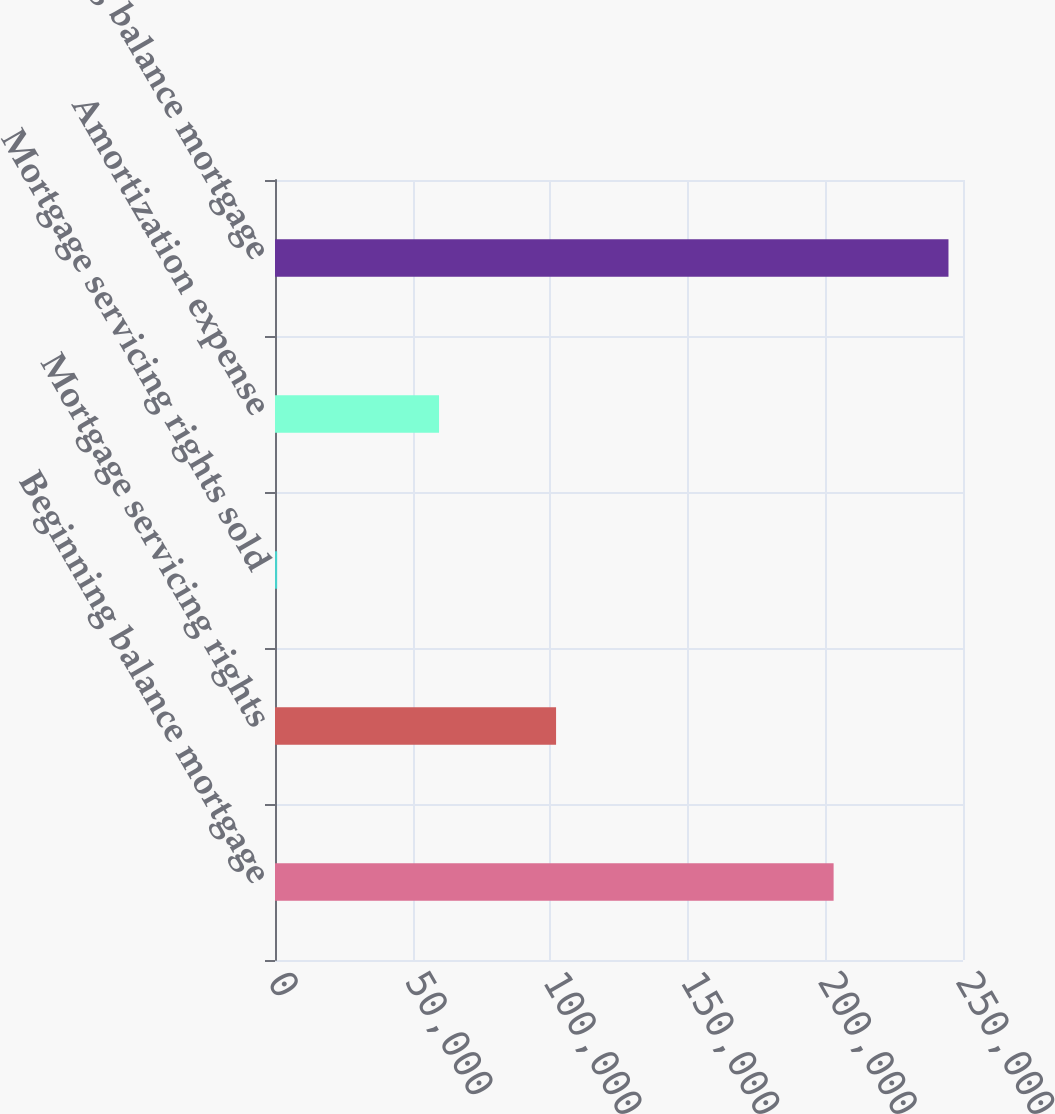Convert chart to OTSL. <chart><loc_0><loc_0><loc_500><loc_500><bar_chart><fcel>Beginning balance mortgage<fcel>Mortgage servicing rights<fcel>Mortgage servicing rights sold<fcel>Amortization expense<fcel>Ending balance mortgage<nl><fcel>202982<fcel>102132<fcel>783<fcel>59608<fcel>244723<nl></chart> 